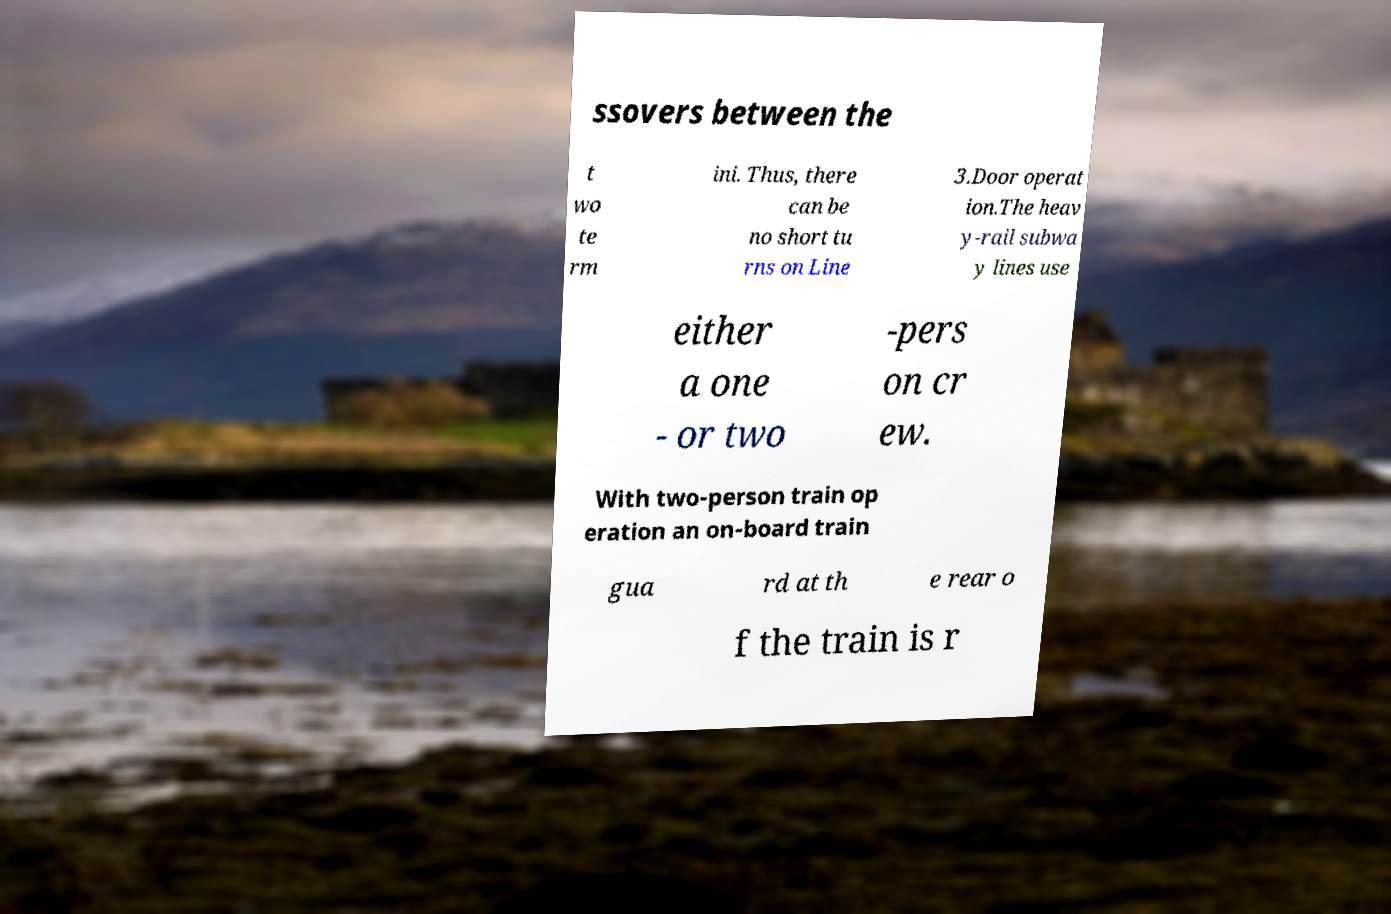For documentation purposes, I need the text within this image transcribed. Could you provide that? ssovers between the t wo te rm ini. Thus, there can be no short tu rns on Line 3.Door operat ion.The heav y-rail subwa y lines use either a one - or two -pers on cr ew. With two-person train op eration an on-board train gua rd at th e rear o f the train is r 